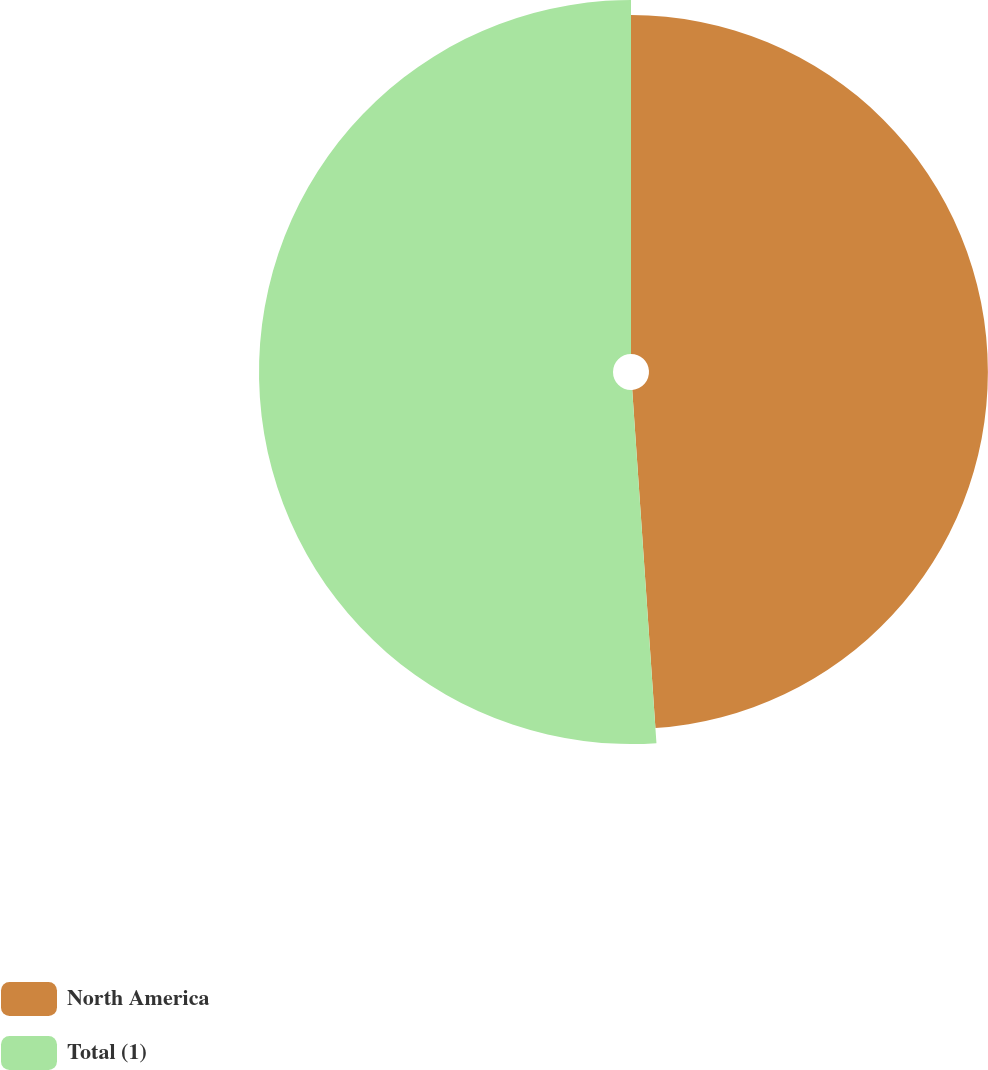<chart> <loc_0><loc_0><loc_500><loc_500><pie_chart><fcel>North America<fcel>Total (1)<nl><fcel>48.91%<fcel>51.09%<nl></chart> 